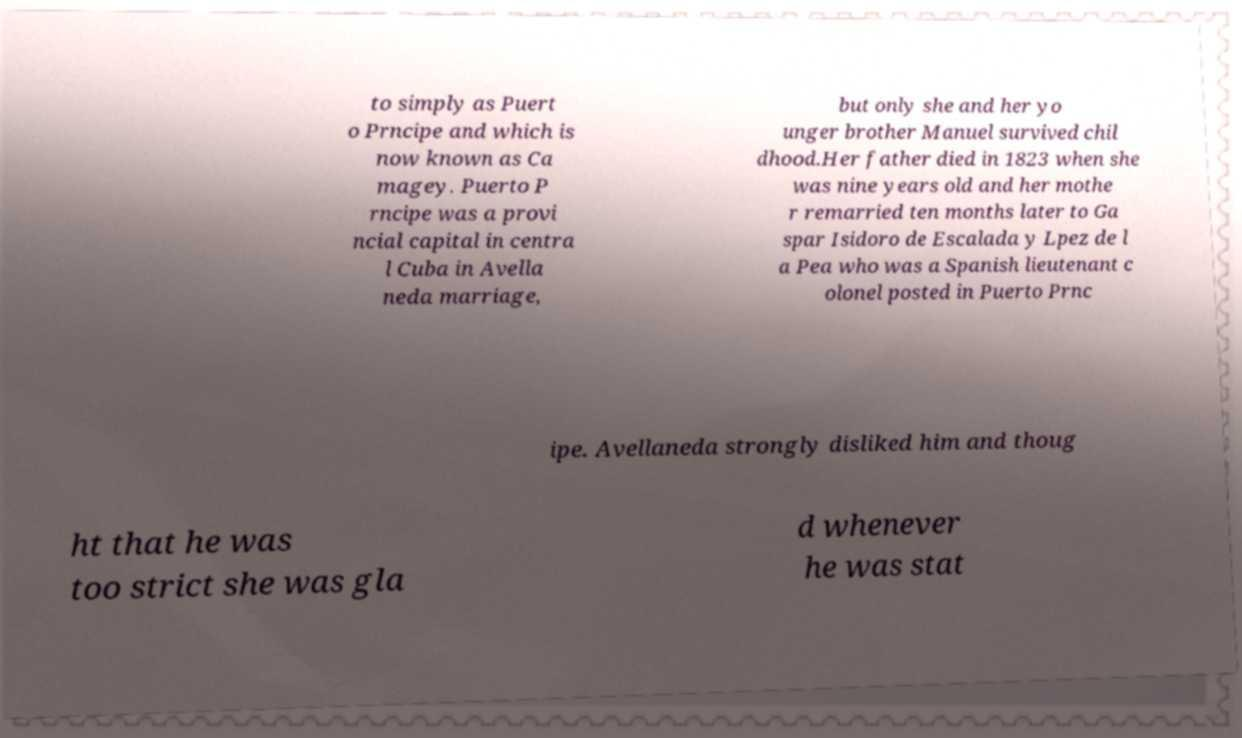Could you extract and type out the text from this image? to simply as Puert o Prncipe and which is now known as Ca magey. Puerto P rncipe was a provi ncial capital in centra l Cuba in Avella neda marriage, but only she and her yo unger brother Manuel survived chil dhood.Her father died in 1823 when she was nine years old and her mothe r remarried ten months later to Ga spar Isidoro de Escalada y Lpez de l a Pea who was a Spanish lieutenant c olonel posted in Puerto Prnc ipe. Avellaneda strongly disliked him and thoug ht that he was too strict she was gla d whenever he was stat 